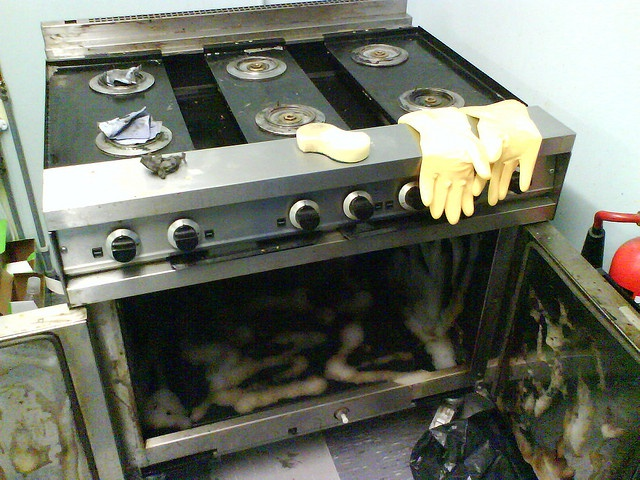Describe the objects in this image and their specific colors. I can see a oven in beige, black, gray, darkgreen, and darkgray tones in this image. 